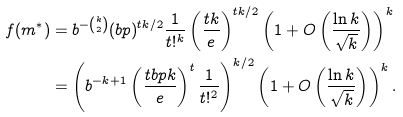<formula> <loc_0><loc_0><loc_500><loc_500>f ( m ^ { * } ) & = b ^ { - \binom { k } { 2 } } ( b p ) ^ { t k / 2 } \frac { 1 } { t ! ^ { k } } \left ( \frac { t k } { e } \right ) ^ { t k / 2 } \left ( 1 + O \left ( \frac { \ln k } { \sqrt { k } } \right ) \right ) ^ { k } \\ & = \left ( b ^ { - k + 1 } \left ( \frac { t b p k } { e } \right ) ^ { t } \frac { 1 } { t ! ^ { 2 } } \right ) ^ { k / 2 } \left ( 1 + O \left ( \frac { \ln k } { \sqrt { k } } \right ) \right ) ^ { k } .</formula> 